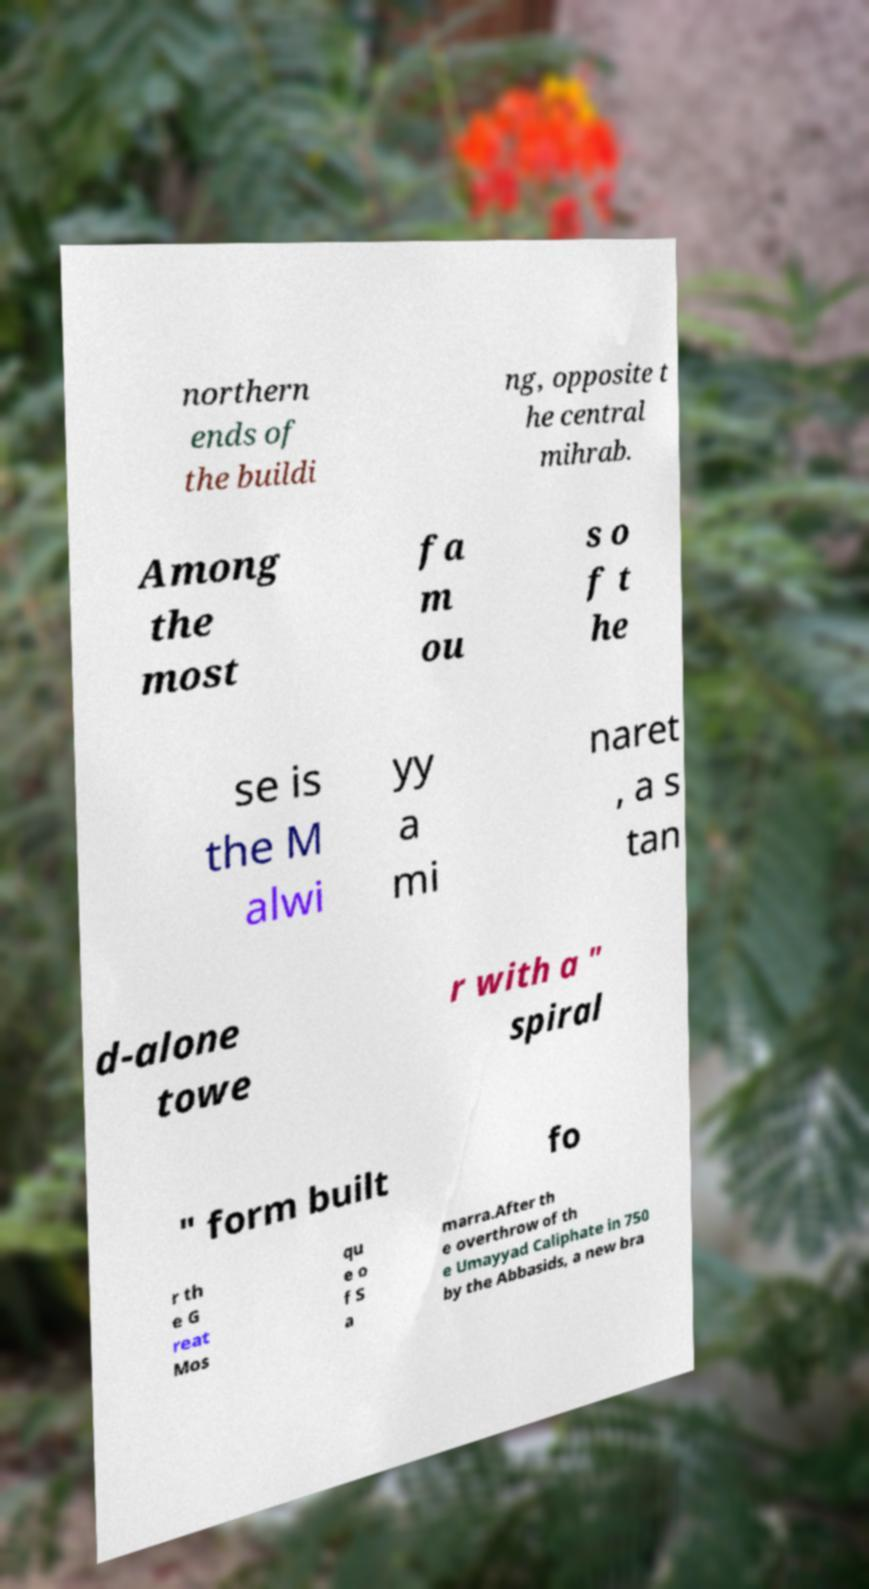Please identify and transcribe the text found in this image. northern ends of the buildi ng, opposite t he central mihrab. Among the most fa m ou s o f t he se is the M alwi yy a mi naret , a s tan d-alone towe r with a " spiral " form built fo r th e G reat Mos qu e o f S a marra.After th e overthrow of th e Umayyad Caliphate in 750 by the Abbasids, a new bra 